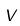<formula> <loc_0><loc_0><loc_500><loc_500>V</formula> 